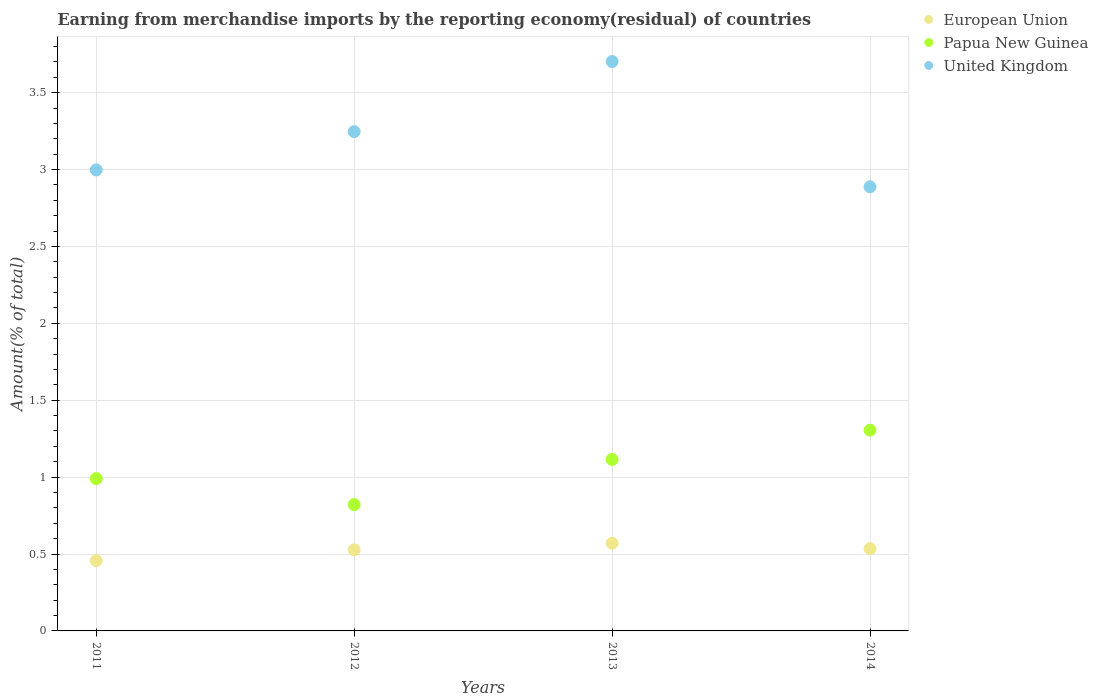Is the number of dotlines equal to the number of legend labels?
Offer a very short reply. Yes. What is the percentage of amount earned from merchandise imports in Papua New Guinea in 2013?
Provide a succinct answer. 1.12. Across all years, what is the maximum percentage of amount earned from merchandise imports in European Union?
Give a very brief answer. 0.57. Across all years, what is the minimum percentage of amount earned from merchandise imports in United Kingdom?
Make the answer very short. 2.89. What is the total percentage of amount earned from merchandise imports in United Kingdom in the graph?
Ensure brevity in your answer.  12.83. What is the difference between the percentage of amount earned from merchandise imports in United Kingdom in 2013 and that in 2014?
Your answer should be very brief. 0.81. What is the difference between the percentage of amount earned from merchandise imports in European Union in 2013 and the percentage of amount earned from merchandise imports in Papua New Guinea in 2014?
Make the answer very short. -0.73. What is the average percentage of amount earned from merchandise imports in European Union per year?
Provide a short and direct response. 0.52. In the year 2014, what is the difference between the percentage of amount earned from merchandise imports in European Union and percentage of amount earned from merchandise imports in United Kingdom?
Your answer should be compact. -2.35. What is the ratio of the percentage of amount earned from merchandise imports in Papua New Guinea in 2013 to that in 2014?
Your answer should be compact. 0.85. Is the difference between the percentage of amount earned from merchandise imports in European Union in 2011 and 2013 greater than the difference between the percentage of amount earned from merchandise imports in United Kingdom in 2011 and 2013?
Provide a succinct answer. Yes. What is the difference between the highest and the second highest percentage of amount earned from merchandise imports in United Kingdom?
Offer a terse response. 0.46. What is the difference between the highest and the lowest percentage of amount earned from merchandise imports in Papua New Guinea?
Offer a very short reply. 0.48. Is the sum of the percentage of amount earned from merchandise imports in Papua New Guinea in 2011 and 2013 greater than the maximum percentage of amount earned from merchandise imports in European Union across all years?
Keep it short and to the point. Yes. Does the percentage of amount earned from merchandise imports in Papua New Guinea monotonically increase over the years?
Ensure brevity in your answer.  No. How many dotlines are there?
Make the answer very short. 3. How many years are there in the graph?
Offer a very short reply. 4. What is the difference between two consecutive major ticks on the Y-axis?
Your answer should be compact. 0.5. What is the title of the graph?
Keep it short and to the point. Earning from merchandise imports by the reporting economy(residual) of countries. What is the label or title of the Y-axis?
Offer a terse response. Amount(% of total). What is the Amount(% of total) in European Union in 2011?
Offer a very short reply. 0.46. What is the Amount(% of total) in Papua New Guinea in 2011?
Your answer should be compact. 0.99. What is the Amount(% of total) of United Kingdom in 2011?
Your answer should be very brief. 3. What is the Amount(% of total) in European Union in 2012?
Ensure brevity in your answer.  0.53. What is the Amount(% of total) of Papua New Guinea in 2012?
Your response must be concise. 0.82. What is the Amount(% of total) of United Kingdom in 2012?
Ensure brevity in your answer.  3.25. What is the Amount(% of total) in European Union in 2013?
Your answer should be very brief. 0.57. What is the Amount(% of total) of Papua New Guinea in 2013?
Provide a succinct answer. 1.12. What is the Amount(% of total) of United Kingdom in 2013?
Provide a short and direct response. 3.7. What is the Amount(% of total) in European Union in 2014?
Provide a succinct answer. 0.53. What is the Amount(% of total) in Papua New Guinea in 2014?
Your answer should be compact. 1.31. What is the Amount(% of total) in United Kingdom in 2014?
Provide a succinct answer. 2.89. Across all years, what is the maximum Amount(% of total) in European Union?
Ensure brevity in your answer.  0.57. Across all years, what is the maximum Amount(% of total) of Papua New Guinea?
Offer a very short reply. 1.31. Across all years, what is the maximum Amount(% of total) of United Kingdom?
Your response must be concise. 3.7. Across all years, what is the minimum Amount(% of total) of European Union?
Keep it short and to the point. 0.46. Across all years, what is the minimum Amount(% of total) of Papua New Guinea?
Keep it short and to the point. 0.82. Across all years, what is the minimum Amount(% of total) of United Kingdom?
Provide a short and direct response. 2.89. What is the total Amount(% of total) in European Union in the graph?
Offer a very short reply. 2.09. What is the total Amount(% of total) of Papua New Guinea in the graph?
Your answer should be very brief. 4.23. What is the total Amount(% of total) in United Kingdom in the graph?
Make the answer very short. 12.83. What is the difference between the Amount(% of total) in European Union in 2011 and that in 2012?
Keep it short and to the point. -0.07. What is the difference between the Amount(% of total) in Papua New Guinea in 2011 and that in 2012?
Provide a short and direct response. 0.17. What is the difference between the Amount(% of total) of United Kingdom in 2011 and that in 2012?
Offer a terse response. -0.25. What is the difference between the Amount(% of total) in European Union in 2011 and that in 2013?
Your answer should be compact. -0.11. What is the difference between the Amount(% of total) in Papua New Guinea in 2011 and that in 2013?
Offer a very short reply. -0.12. What is the difference between the Amount(% of total) of United Kingdom in 2011 and that in 2013?
Give a very brief answer. -0.7. What is the difference between the Amount(% of total) in European Union in 2011 and that in 2014?
Ensure brevity in your answer.  -0.08. What is the difference between the Amount(% of total) in Papua New Guinea in 2011 and that in 2014?
Offer a very short reply. -0.32. What is the difference between the Amount(% of total) of United Kingdom in 2011 and that in 2014?
Make the answer very short. 0.11. What is the difference between the Amount(% of total) in European Union in 2012 and that in 2013?
Provide a succinct answer. -0.04. What is the difference between the Amount(% of total) of Papua New Guinea in 2012 and that in 2013?
Your answer should be very brief. -0.29. What is the difference between the Amount(% of total) of United Kingdom in 2012 and that in 2013?
Your response must be concise. -0.46. What is the difference between the Amount(% of total) in European Union in 2012 and that in 2014?
Your answer should be very brief. -0.01. What is the difference between the Amount(% of total) of Papua New Guinea in 2012 and that in 2014?
Offer a very short reply. -0.48. What is the difference between the Amount(% of total) in United Kingdom in 2012 and that in 2014?
Offer a very short reply. 0.36. What is the difference between the Amount(% of total) of European Union in 2013 and that in 2014?
Provide a succinct answer. 0.04. What is the difference between the Amount(% of total) of Papua New Guinea in 2013 and that in 2014?
Ensure brevity in your answer.  -0.19. What is the difference between the Amount(% of total) of United Kingdom in 2013 and that in 2014?
Your answer should be very brief. 0.81. What is the difference between the Amount(% of total) in European Union in 2011 and the Amount(% of total) in Papua New Guinea in 2012?
Offer a terse response. -0.36. What is the difference between the Amount(% of total) of European Union in 2011 and the Amount(% of total) of United Kingdom in 2012?
Provide a succinct answer. -2.79. What is the difference between the Amount(% of total) of Papua New Guinea in 2011 and the Amount(% of total) of United Kingdom in 2012?
Keep it short and to the point. -2.26. What is the difference between the Amount(% of total) in European Union in 2011 and the Amount(% of total) in Papua New Guinea in 2013?
Ensure brevity in your answer.  -0.66. What is the difference between the Amount(% of total) of European Union in 2011 and the Amount(% of total) of United Kingdom in 2013?
Ensure brevity in your answer.  -3.25. What is the difference between the Amount(% of total) of Papua New Guinea in 2011 and the Amount(% of total) of United Kingdom in 2013?
Your response must be concise. -2.71. What is the difference between the Amount(% of total) of European Union in 2011 and the Amount(% of total) of Papua New Guinea in 2014?
Your answer should be compact. -0.85. What is the difference between the Amount(% of total) in European Union in 2011 and the Amount(% of total) in United Kingdom in 2014?
Your response must be concise. -2.43. What is the difference between the Amount(% of total) in Papua New Guinea in 2011 and the Amount(% of total) in United Kingdom in 2014?
Your answer should be compact. -1.9. What is the difference between the Amount(% of total) in European Union in 2012 and the Amount(% of total) in Papua New Guinea in 2013?
Offer a terse response. -0.59. What is the difference between the Amount(% of total) in European Union in 2012 and the Amount(% of total) in United Kingdom in 2013?
Your answer should be very brief. -3.18. What is the difference between the Amount(% of total) in Papua New Guinea in 2012 and the Amount(% of total) in United Kingdom in 2013?
Ensure brevity in your answer.  -2.88. What is the difference between the Amount(% of total) of European Union in 2012 and the Amount(% of total) of Papua New Guinea in 2014?
Keep it short and to the point. -0.78. What is the difference between the Amount(% of total) of European Union in 2012 and the Amount(% of total) of United Kingdom in 2014?
Provide a short and direct response. -2.36. What is the difference between the Amount(% of total) of Papua New Guinea in 2012 and the Amount(% of total) of United Kingdom in 2014?
Your response must be concise. -2.07. What is the difference between the Amount(% of total) of European Union in 2013 and the Amount(% of total) of Papua New Guinea in 2014?
Provide a succinct answer. -0.73. What is the difference between the Amount(% of total) in European Union in 2013 and the Amount(% of total) in United Kingdom in 2014?
Offer a terse response. -2.32. What is the difference between the Amount(% of total) of Papua New Guinea in 2013 and the Amount(% of total) of United Kingdom in 2014?
Offer a terse response. -1.77. What is the average Amount(% of total) of European Union per year?
Your answer should be very brief. 0.52. What is the average Amount(% of total) in Papua New Guinea per year?
Keep it short and to the point. 1.06. What is the average Amount(% of total) in United Kingdom per year?
Keep it short and to the point. 3.21. In the year 2011, what is the difference between the Amount(% of total) of European Union and Amount(% of total) of Papua New Guinea?
Ensure brevity in your answer.  -0.53. In the year 2011, what is the difference between the Amount(% of total) in European Union and Amount(% of total) in United Kingdom?
Make the answer very short. -2.54. In the year 2011, what is the difference between the Amount(% of total) of Papua New Guinea and Amount(% of total) of United Kingdom?
Offer a very short reply. -2.01. In the year 2012, what is the difference between the Amount(% of total) in European Union and Amount(% of total) in Papua New Guinea?
Offer a very short reply. -0.29. In the year 2012, what is the difference between the Amount(% of total) in European Union and Amount(% of total) in United Kingdom?
Keep it short and to the point. -2.72. In the year 2012, what is the difference between the Amount(% of total) in Papua New Guinea and Amount(% of total) in United Kingdom?
Give a very brief answer. -2.43. In the year 2013, what is the difference between the Amount(% of total) in European Union and Amount(% of total) in Papua New Guinea?
Provide a succinct answer. -0.54. In the year 2013, what is the difference between the Amount(% of total) of European Union and Amount(% of total) of United Kingdom?
Your response must be concise. -3.13. In the year 2013, what is the difference between the Amount(% of total) of Papua New Guinea and Amount(% of total) of United Kingdom?
Provide a short and direct response. -2.59. In the year 2014, what is the difference between the Amount(% of total) in European Union and Amount(% of total) in Papua New Guinea?
Your answer should be compact. -0.77. In the year 2014, what is the difference between the Amount(% of total) in European Union and Amount(% of total) in United Kingdom?
Your answer should be very brief. -2.35. In the year 2014, what is the difference between the Amount(% of total) of Papua New Guinea and Amount(% of total) of United Kingdom?
Offer a terse response. -1.58. What is the ratio of the Amount(% of total) in European Union in 2011 to that in 2012?
Offer a terse response. 0.87. What is the ratio of the Amount(% of total) of Papua New Guinea in 2011 to that in 2012?
Your answer should be compact. 1.21. What is the ratio of the Amount(% of total) in United Kingdom in 2011 to that in 2012?
Ensure brevity in your answer.  0.92. What is the ratio of the Amount(% of total) in European Union in 2011 to that in 2013?
Provide a short and direct response. 0.8. What is the ratio of the Amount(% of total) in Papua New Guinea in 2011 to that in 2013?
Provide a succinct answer. 0.89. What is the ratio of the Amount(% of total) in United Kingdom in 2011 to that in 2013?
Provide a short and direct response. 0.81. What is the ratio of the Amount(% of total) in European Union in 2011 to that in 2014?
Make the answer very short. 0.85. What is the ratio of the Amount(% of total) of Papua New Guinea in 2011 to that in 2014?
Your answer should be compact. 0.76. What is the ratio of the Amount(% of total) in United Kingdom in 2011 to that in 2014?
Provide a short and direct response. 1.04. What is the ratio of the Amount(% of total) in European Union in 2012 to that in 2013?
Ensure brevity in your answer.  0.92. What is the ratio of the Amount(% of total) of Papua New Guinea in 2012 to that in 2013?
Your response must be concise. 0.74. What is the ratio of the Amount(% of total) in United Kingdom in 2012 to that in 2013?
Provide a succinct answer. 0.88. What is the ratio of the Amount(% of total) of European Union in 2012 to that in 2014?
Your answer should be very brief. 0.99. What is the ratio of the Amount(% of total) in Papua New Guinea in 2012 to that in 2014?
Provide a succinct answer. 0.63. What is the ratio of the Amount(% of total) in United Kingdom in 2012 to that in 2014?
Keep it short and to the point. 1.12. What is the ratio of the Amount(% of total) of European Union in 2013 to that in 2014?
Provide a short and direct response. 1.07. What is the ratio of the Amount(% of total) in Papua New Guinea in 2013 to that in 2014?
Keep it short and to the point. 0.85. What is the ratio of the Amount(% of total) in United Kingdom in 2013 to that in 2014?
Your answer should be compact. 1.28. What is the difference between the highest and the second highest Amount(% of total) in European Union?
Give a very brief answer. 0.04. What is the difference between the highest and the second highest Amount(% of total) of Papua New Guinea?
Your answer should be compact. 0.19. What is the difference between the highest and the second highest Amount(% of total) of United Kingdom?
Your answer should be compact. 0.46. What is the difference between the highest and the lowest Amount(% of total) in European Union?
Make the answer very short. 0.11. What is the difference between the highest and the lowest Amount(% of total) in Papua New Guinea?
Provide a succinct answer. 0.48. What is the difference between the highest and the lowest Amount(% of total) of United Kingdom?
Provide a short and direct response. 0.81. 